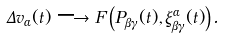Convert formula to latex. <formula><loc_0><loc_0><loc_500><loc_500>\Delta v _ { \alpha } ( t ) \longrightarrow F \left ( P _ { \beta \gamma } ( t ) , \xi _ { \beta \gamma } ^ { \alpha } ( t ) \right ) .</formula> 